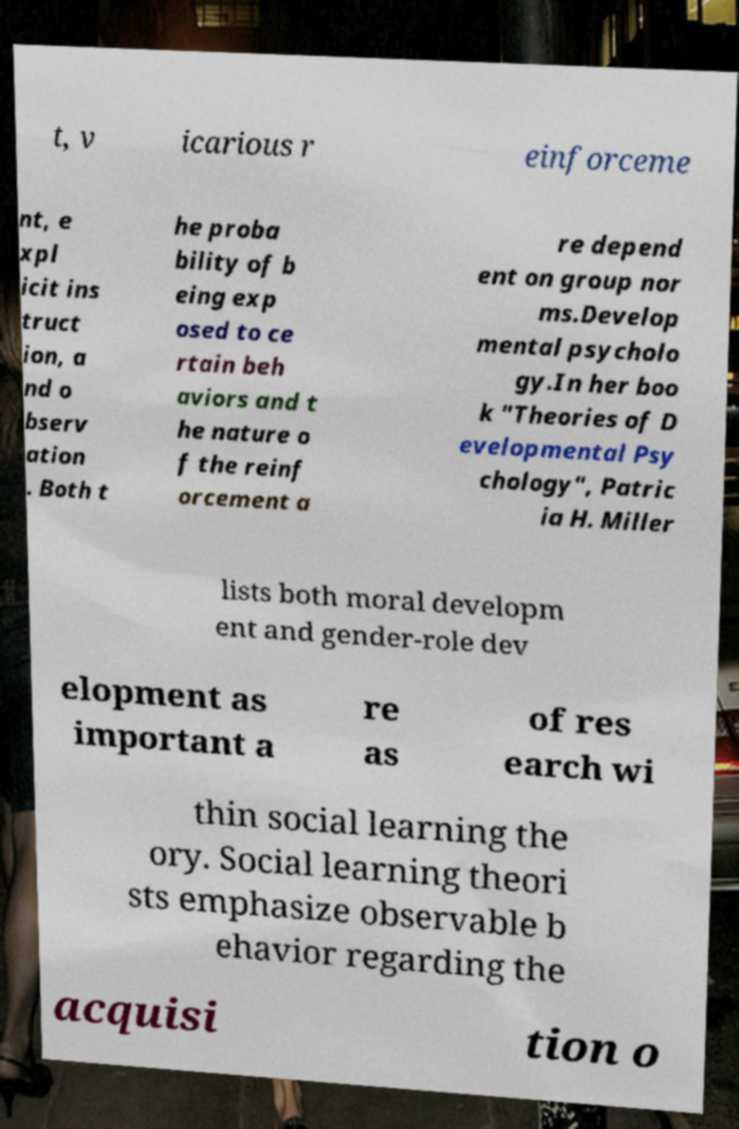Can you accurately transcribe the text from the provided image for me? t, v icarious r einforceme nt, e xpl icit ins truct ion, a nd o bserv ation . Both t he proba bility of b eing exp osed to ce rtain beh aviors and t he nature o f the reinf orcement a re depend ent on group nor ms.Develop mental psycholo gy.In her boo k "Theories of D evelopmental Psy chology", Patric ia H. Miller lists both moral developm ent and gender-role dev elopment as important a re as of res earch wi thin social learning the ory. Social learning theori sts emphasize observable b ehavior regarding the acquisi tion o 